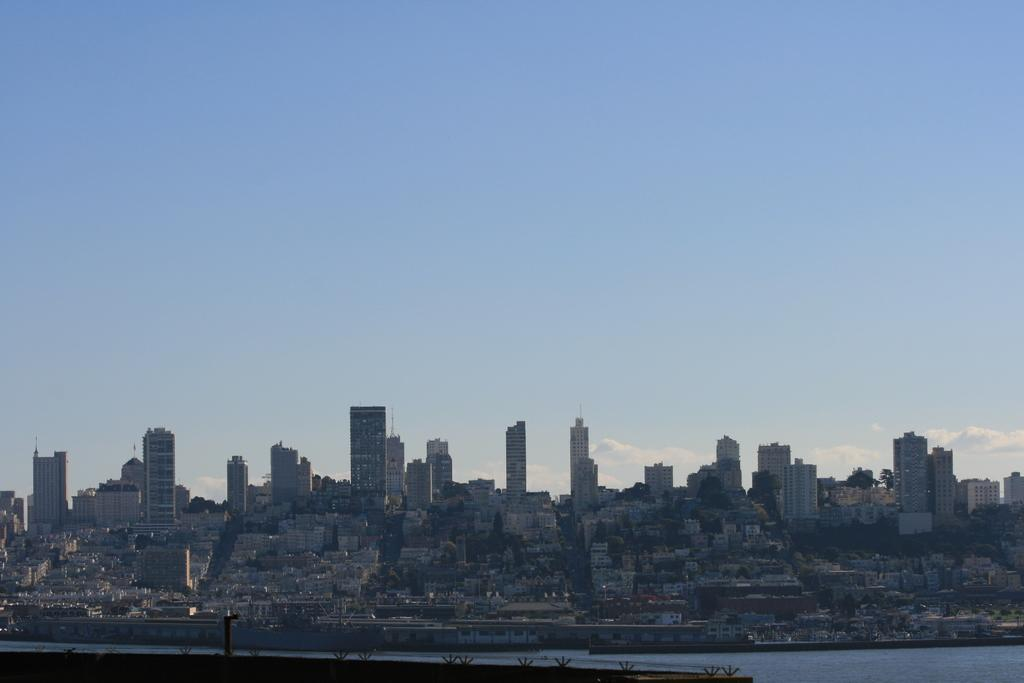What is the main feature in the foreground of the image? There is a water body in the foreground of the image. What can be seen in the background of the image? There are buildings in the background of the image. What part of the natural environment is visible in the image? The sky is visible in the image. Can you describe the sky in the image? There are patches of clouds in the sky. What type of gold can be seen in the image? There is no gold present in the image. What season is depicted in the image based on the presence of snow? The image does not show any snow, so it cannot be determined that it is winter. 